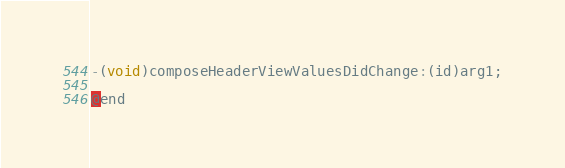Convert code to text. <code><loc_0><loc_0><loc_500><loc_500><_C_>-(void)composeHeaderViewValuesDidChange:(id)arg1;

@end

</code> 